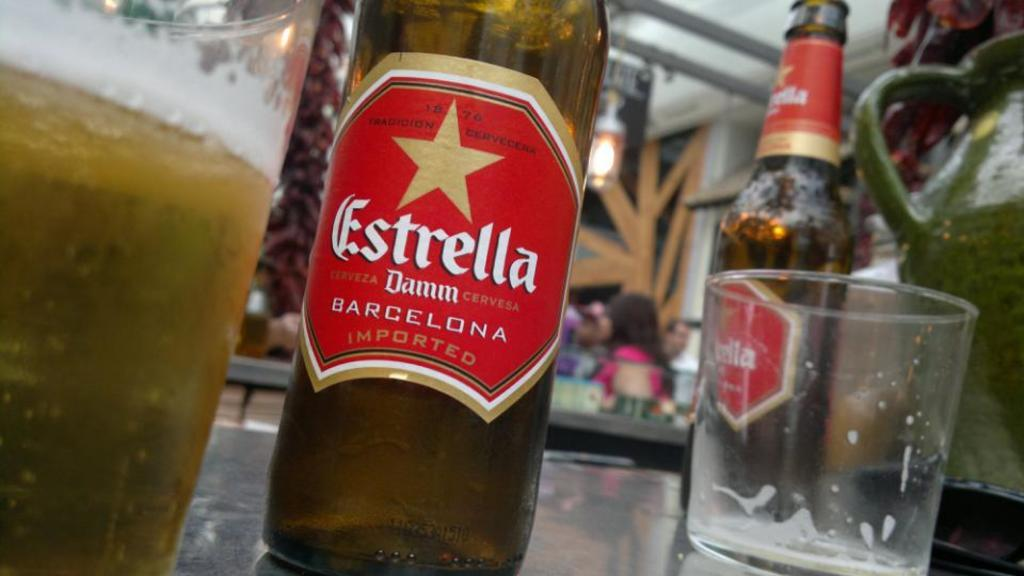What type of containers are visible in the image? There are glass bottles in the image. What other glass object can be seen in the image? There is a glass in the image. What else is present on the table in the image? There are other objects on the table in the image. Can you hear the whistle in the image? There is no whistle present in the image, so it cannot be heard. 